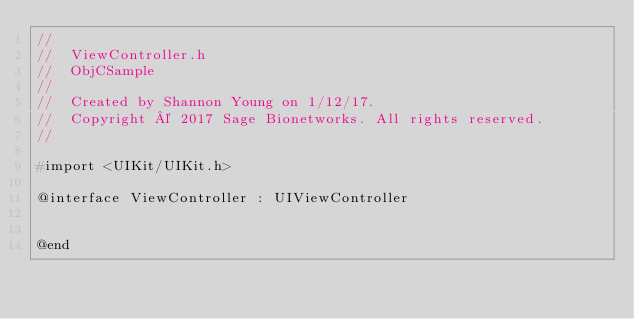Convert code to text. <code><loc_0><loc_0><loc_500><loc_500><_C_>//
//  ViewController.h
//  ObjCSample
//
//  Created by Shannon Young on 1/12/17.
//  Copyright © 2017 Sage Bionetworks. All rights reserved.
//

#import <UIKit/UIKit.h>

@interface ViewController : UIViewController


@end

</code> 